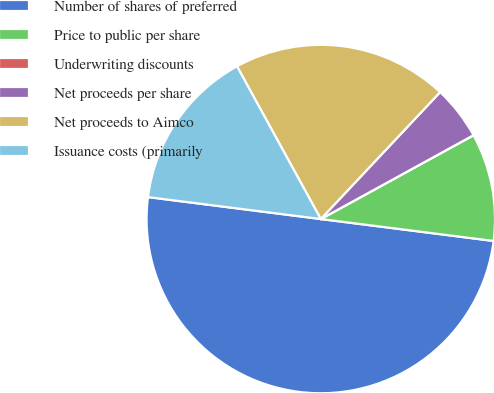Convert chart to OTSL. <chart><loc_0><loc_0><loc_500><loc_500><pie_chart><fcel>Number of shares of preferred<fcel>Price to public per share<fcel>Underwriting discounts<fcel>Net proceeds per share<fcel>Net proceeds to Aimco<fcel>Issuance costs (primarily<nl><fcel>50.0%<fcel>10.0%<fcel>0.0%<fcel>5.0%<fcel>20.0%<fcel>15.0%<nl></chart> 